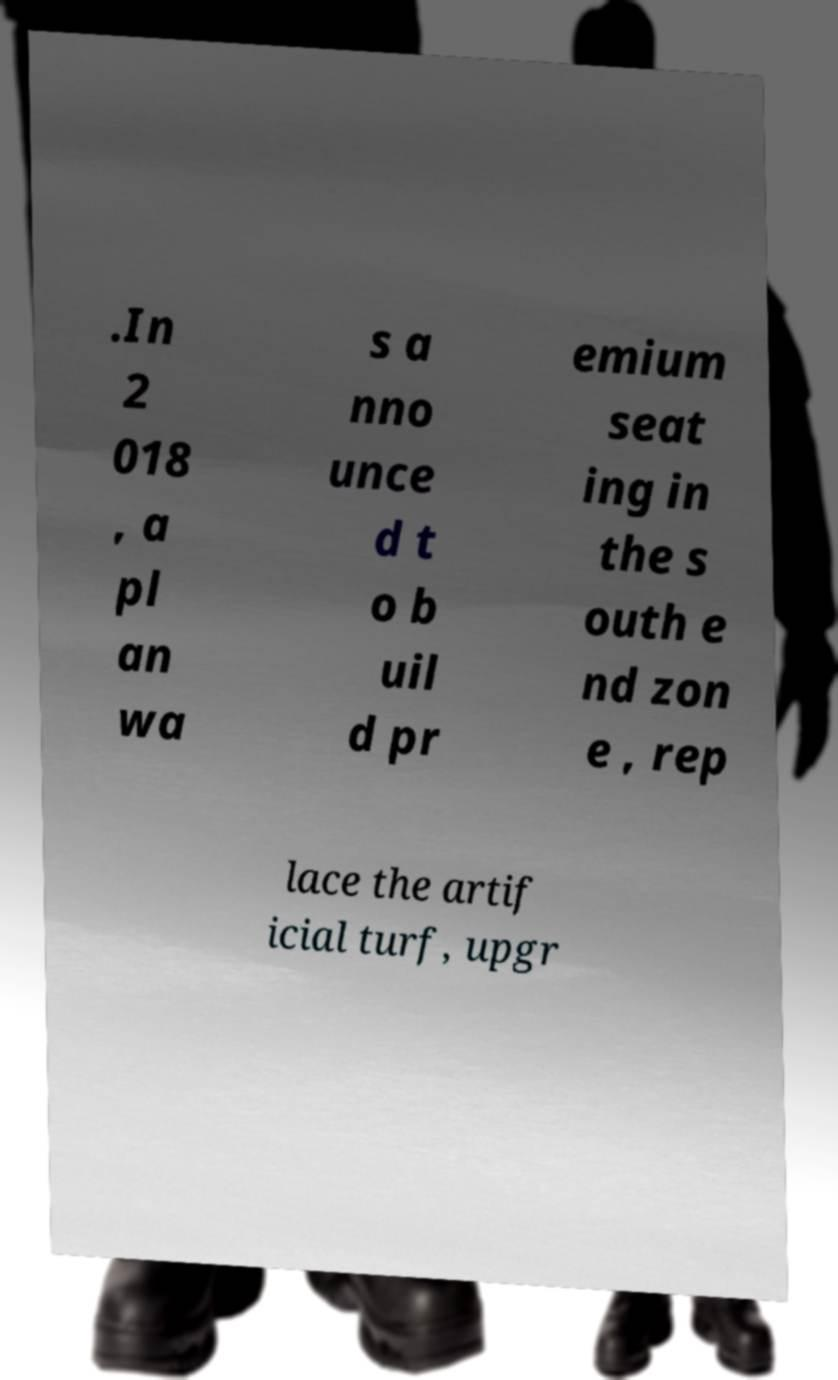For documentation purposes, I need the text within this image transcribed. Could you provide that? .In 2 018 , a pl an wa s a nno unce d t o b uil d pr emium seat ing in the s outh e nd zon e , rep lace the artif icial turf, upgr 